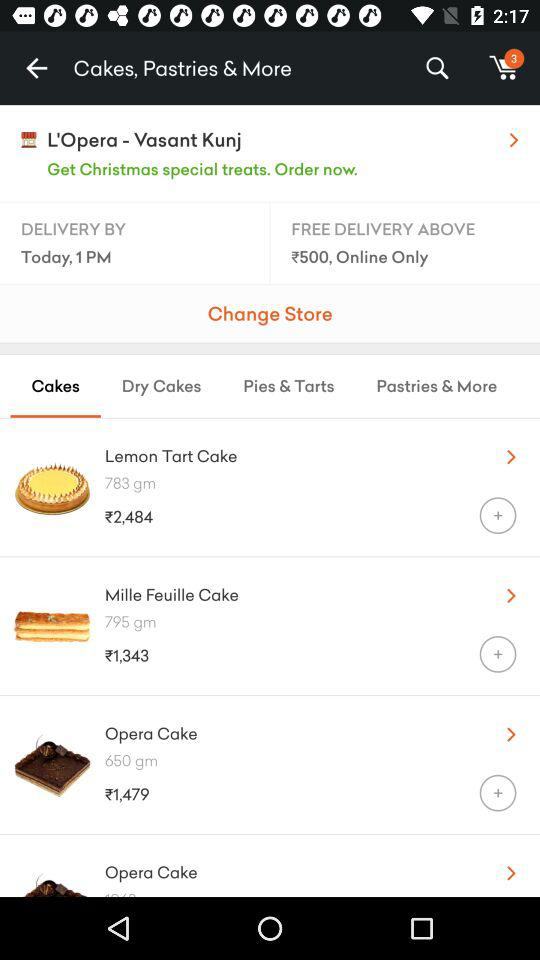Above what amount is the free delivery applicable? The free delivery is applicable above ₹500. 